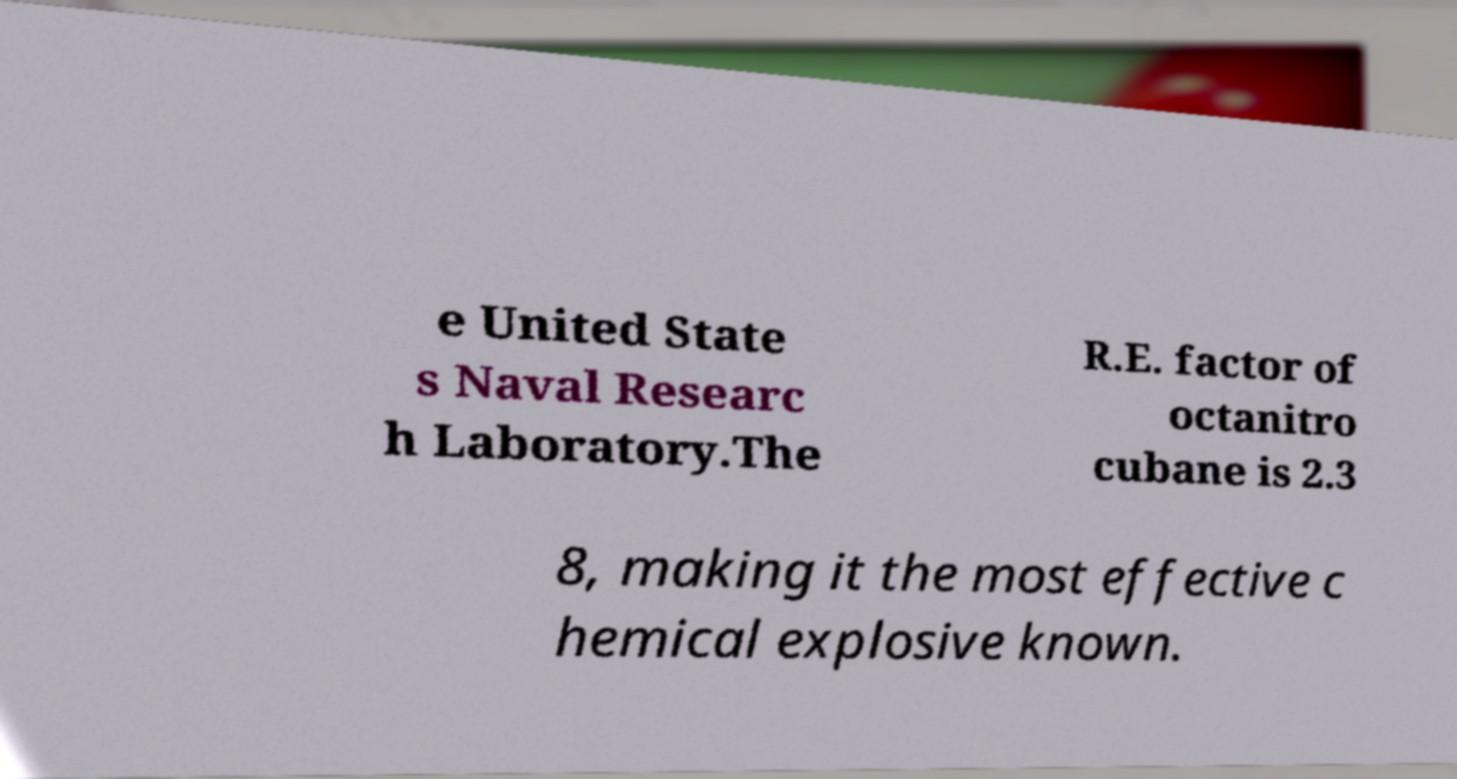Could you assist in decoding the text presented in this image and type it out clearly? e United State s Naval Researc h Laboratory.The R.E. factor of octanitro cubane is 2.3 8, making it the most effective c hemical explosive known. 